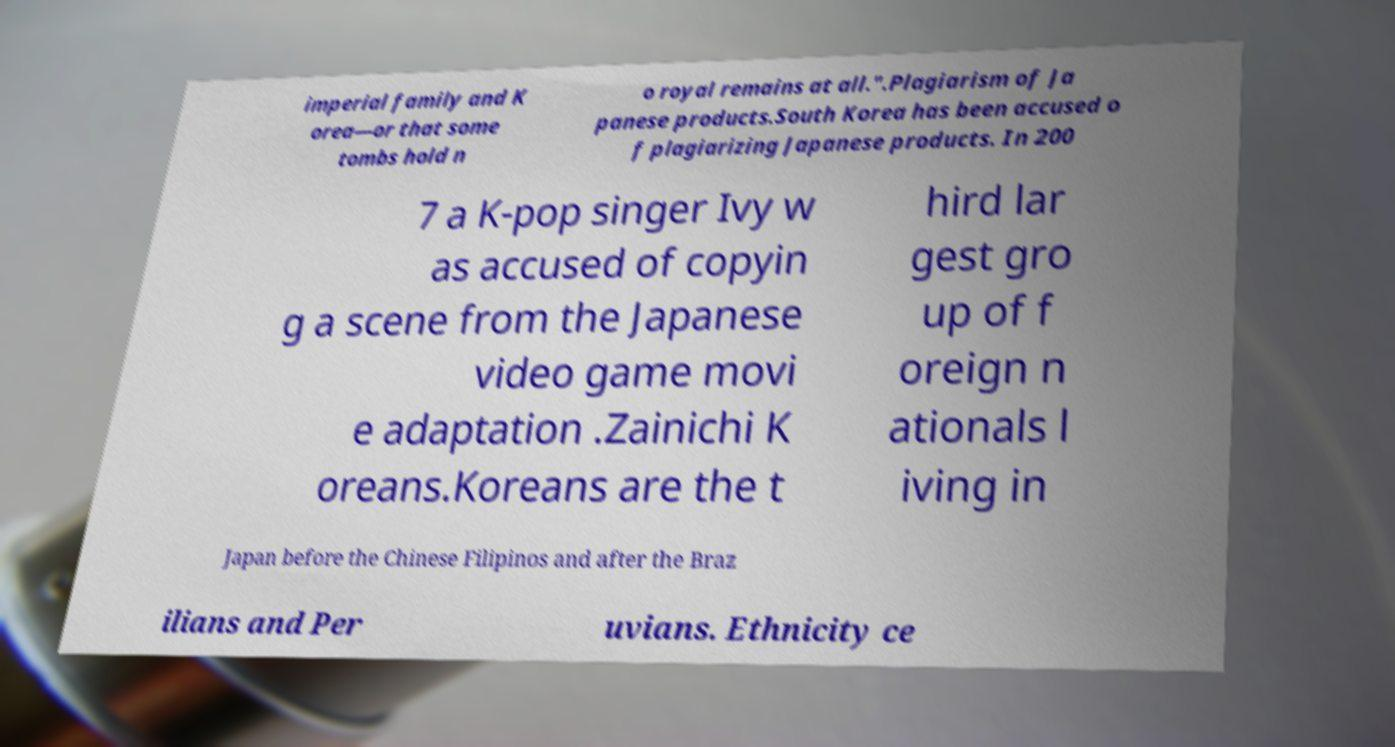Can you accurately transcribe the text from the provided image for me? imperial family and K orea—or that some tombs hold n o royal remains at all.".Plagiarism of Ja panese products.South Korea has been accused o f plagiarizing Japanese products. In 200 7 a K-pop singer Ivy w as accused of copyin g a scene from the Japanese video game movi e adaptation .Zainichi K oreans.Koreans are the t hird lar gest gro up of f oreign n ationals l iving in Japan before the Chinese Filipinos and after the Braz ilians and Per uvians. Ethnicity ce 